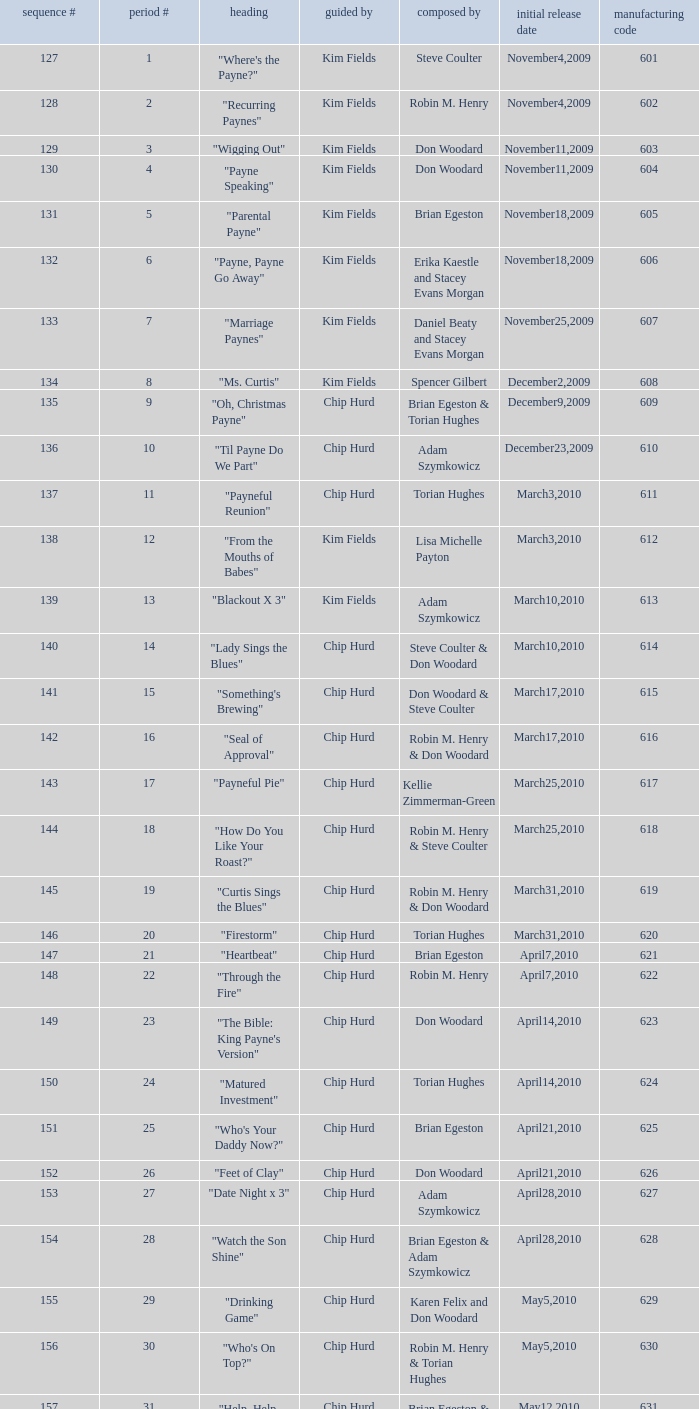What is the original air dates for the title "firestorm"? March31,2010. 